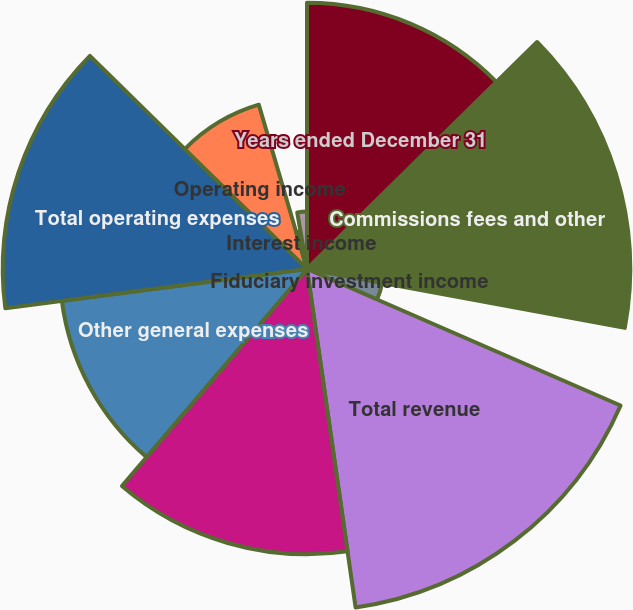Convert chart. <chart><loc_0><loc_0><loc_500><loc_500><pie_chart><fcel>Years ended December 31<fcel>Commissions fees and other<fcel>Fiduciary investment income<fcel>Total revenue<fcel>Compensation and benefits<fcel>Other general expenses<fcel>Total operating expenses<fcel>Operating income<fcel>Interest income<fcel>Interest expense<nl><fcel>12.61%<fcel>15.31%<fcel>3.62%<fcel>16.2%<fcel>13.51%<fcel>11.71%<fcel>14.41%<fcel>8.11%<fcel>1.82%<fcel>2.72%<nl></chart> 